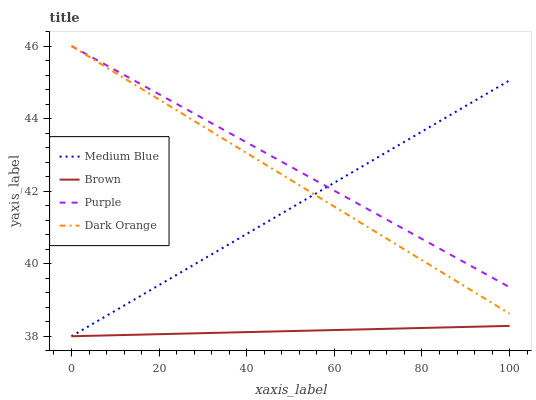Does Medium Blue have the minimum area under the curve?
Answer yes or no. No. Does Medium Blue have the maximum area under the curve?
Answer yes or no. No. Is Medium Blue the smoothest?
Answer yes or no. No. Is Medium Blue the roughest?
Answer yes or no. No. Does Dark Orange have the lowest value?
Answer yes or no. No. Does Medium Blue have the highest value?
Answer yes or no. No. Is Brown less than Purple?
Answer yes or no. Yes. Is Purple greater than Brown?
Answer yes or no. Yes. Does Brown intersect Purple?
Answer yes or no. No. 